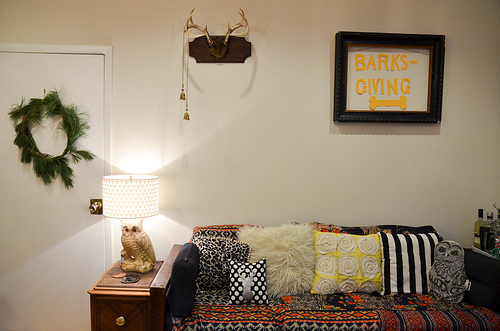<image>
Is the owl next to the sofa? Yes. The owl is positioned adjacent to the sofa, located nearby in the same general area. 